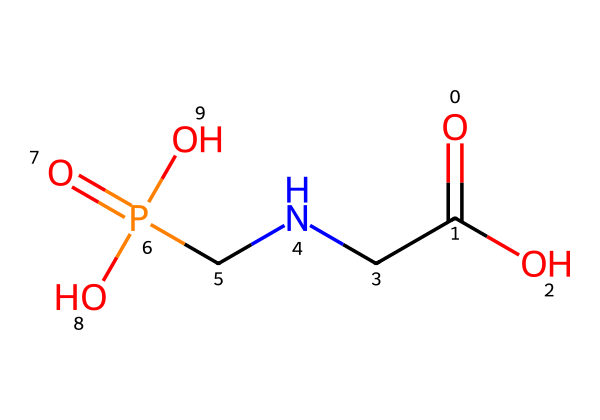What is the primary functional group in glyphosate? The primary functional group present in the chemical structure is the carboxylic acid group indicated by the -COOH part of the molecule.
Answer: carboxylic acid How many nitrogen atoms are in glyphosate? On analyzing the SMILES representation, there is one nitrogen atom present in the chemical structure, specifically in the amine (CN) part of the molecule.
Answer: one What is the total number of oxygen atoms in glyphosate? Counting the oxygen atoms from the -COOH (1), the =O (1), and the two OH groups shows that there are a total of four oxygen atoms in the molecule.
Answer: four What type of herbicide is glyphosate considered? Glyphosate is categorized as a systemic herbicide due to its ability to be absorbed by plants and translocated throughout their structure.
Answer: systemic Does glyphosate have any specific effects on gardens frequented by geriatric patients? Glyphosate can affect non-target plants negatively and has been a concern due to its potential health effects on sensitive populations, including the elderly.
Answer: potential health effects Is glyphosate considered a broad-spectrum herbicide? Yes, glyphosate is classified as a broad-spectrum herbicide because it can control a wide variety of weeds and grasses.
Answer: broad-spectrum 